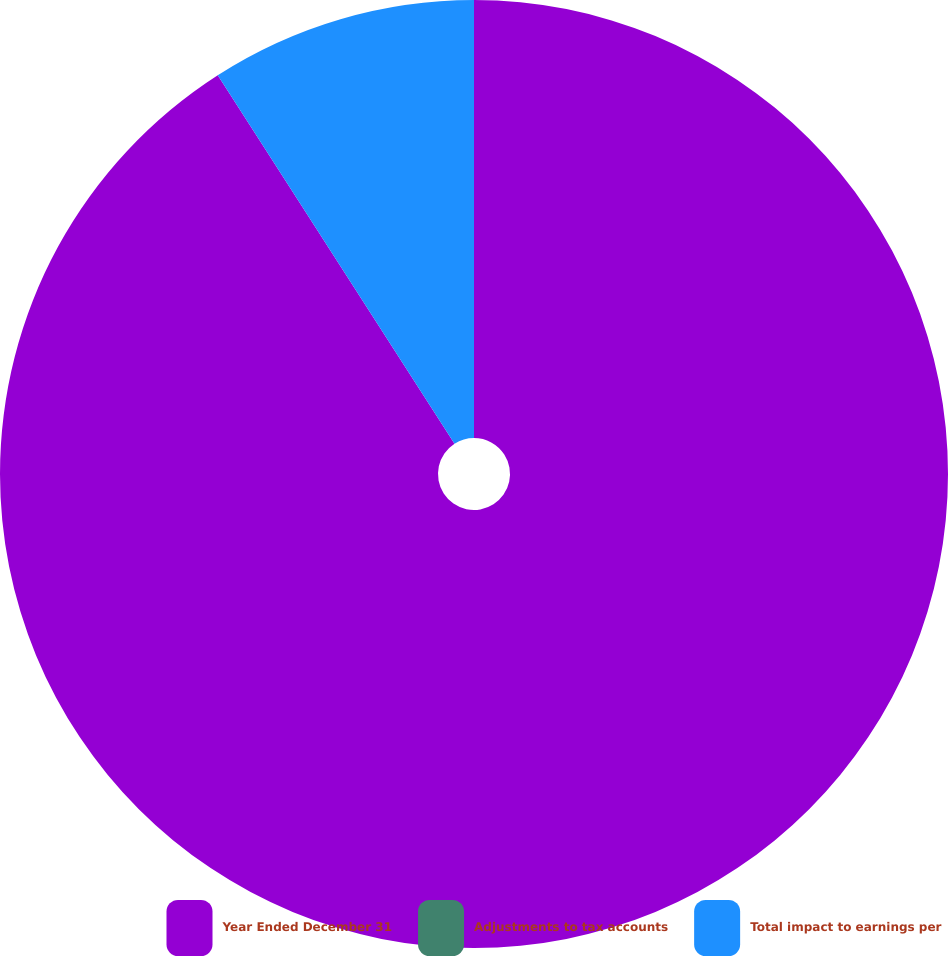<chart> <loc_0><loc_0><loc_500><loc_500><pie_chart><fcel>Year Ended December 31<fcel>Adjustments to tax accounts<fcel>Total impact to earnings per<nl><fcel>90.91%<fcel>0.0%<fcel>9.09%<nl></chart> 